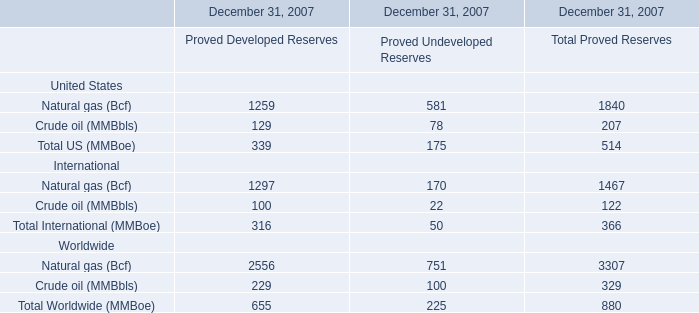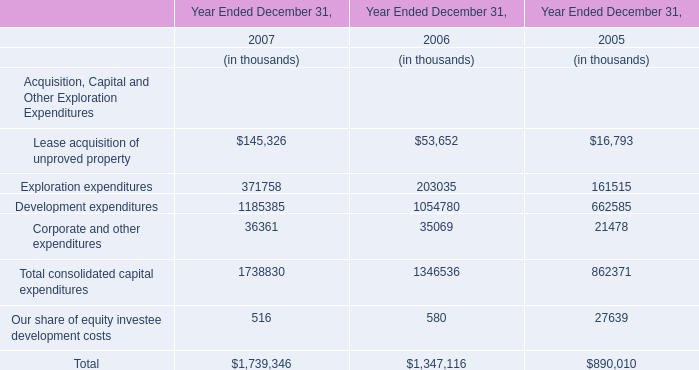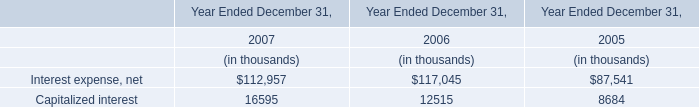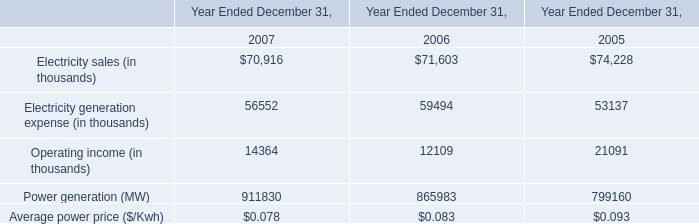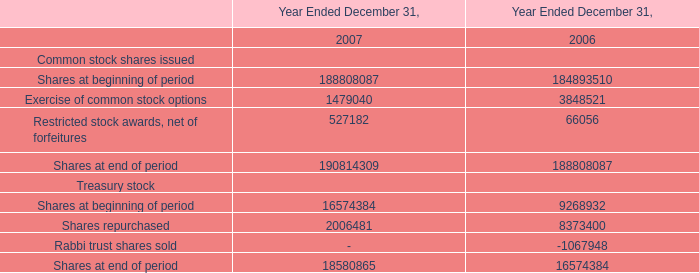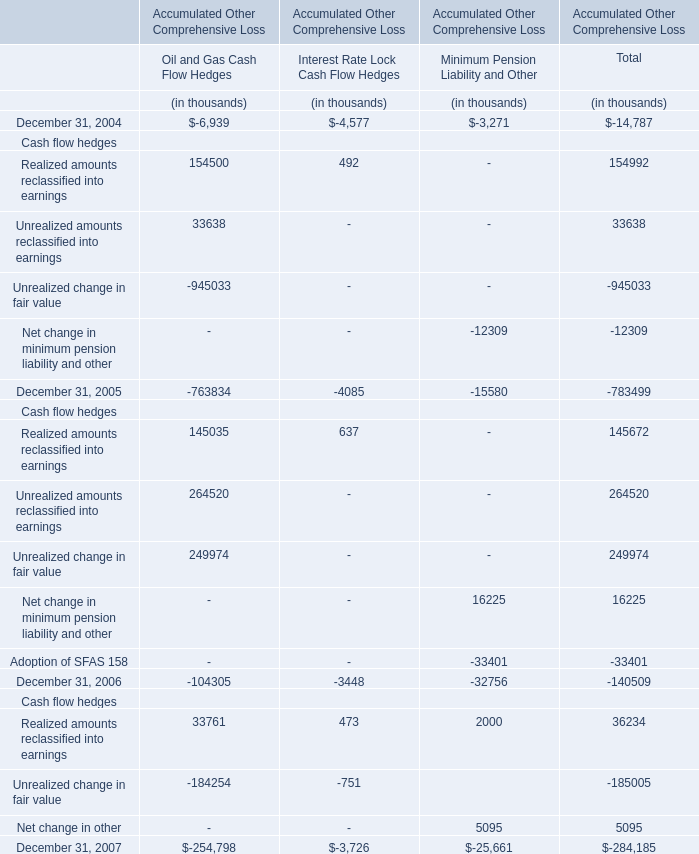Does the average value of Shares at beginning of period in 2007 greater than that in2006 
Answer: yes. 